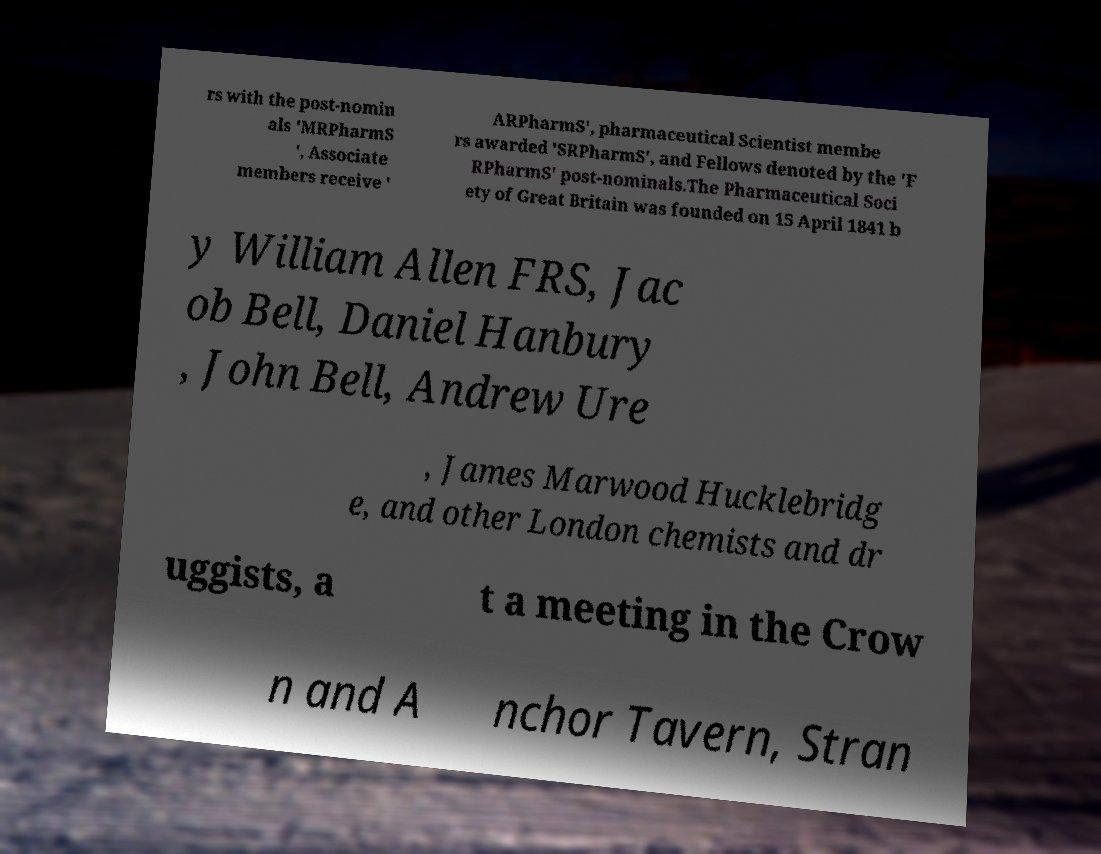For documentation purposes, I need the text within this image transcribed. Could you provide that? rs with the post-nomin als 'MRPharmS ', Associate members receive ' ARPharmS', pharmaceutical Scientist membe rs awarded 'SRPharmS', and Fellows denoted by the 'F RPharmS' post-nominals.The Pharmaceutical Soci ety of Great Britain was founded on 15 April 1841 b y William Allen FRS, Jac ob Bell, Daniel Hanbury , John Bell, Andrew Ure , James Marwood Hucklebridg e, and other London chemists and dr uggists, a t a meeting in the Crow n and A nchor Tavern, Stran 